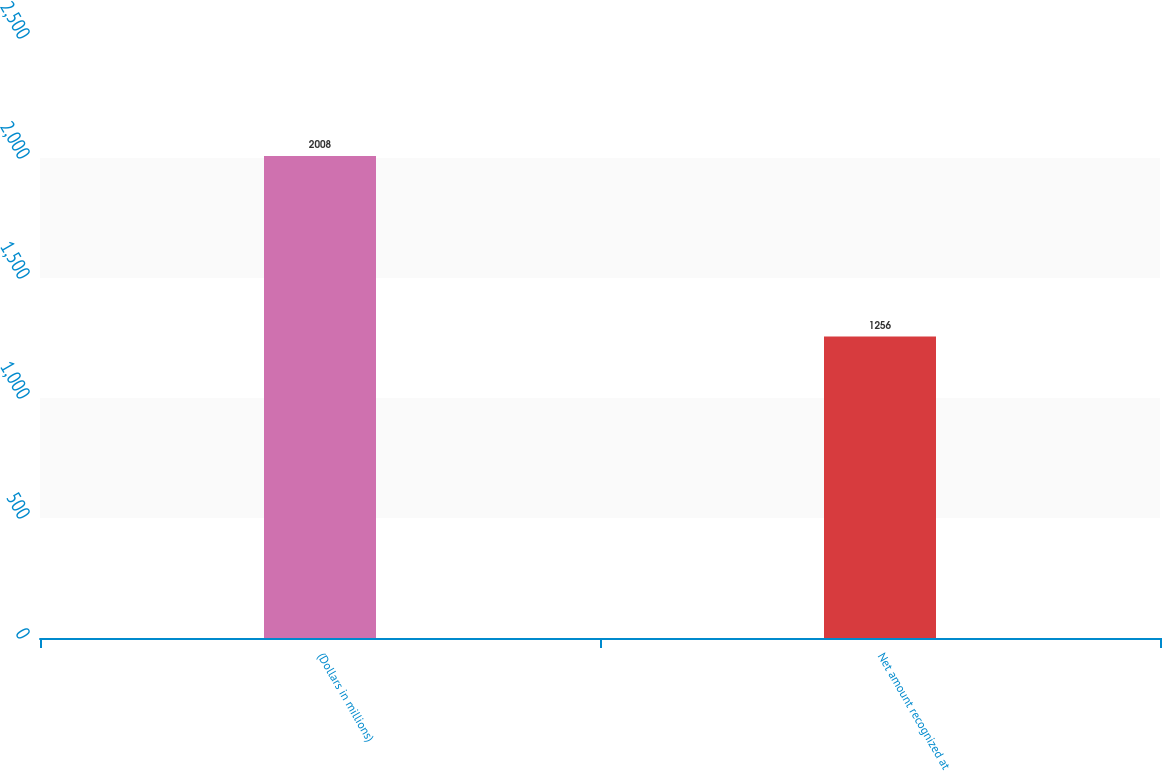Convert chart to OTSL. <chart><loc_0><loc_0><loc_500><loc_500><bar_chart><fcel>(Dollars in millions)<fcel>Net amount recognized at<nl><fcel>2008<fcel>1256<nl></chart> 